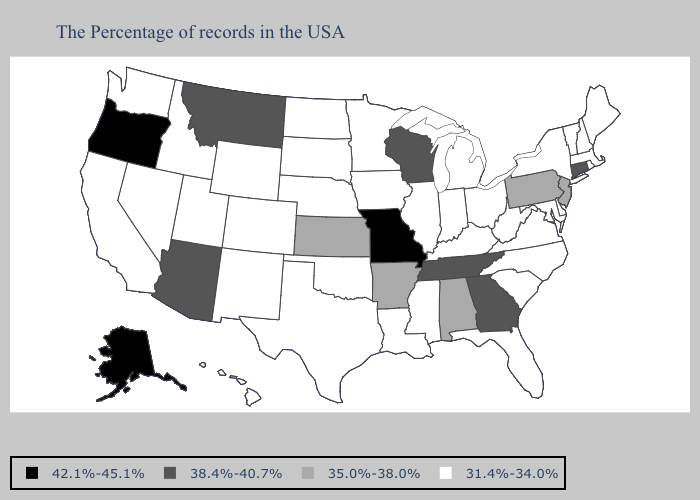What is the value of Massachusetts?
Quick response, please. 31.4%-34.0%. Does Nebraska have the highest value in the MidWest?
Give a very brief answer. No. What is the value of Idaho?
Give a very brief answer. 31.4%-34.0%. Does the first symbol in the legend represent the smallest category?
Concise answer only. No. What is the value of Ohio?
Keep it brief. 31.4%-34.0%. Name the states that have a value in the range 35.0%-38.0%?
Keep it brief. New Jersey, Pennsylvania, Alabama, Arkansas, Kansas. Among the states that border South Carolina , which have the highest value?
Write a very short answer. Georgia. Among the states that border Massachusetts , does Rhode Island have the lowest value?
Concise answer only. Yes. Which states hav the highest value in the South?
Be succinct. Georgia, Tennessee. Name the states that have a value in the range 42.1%-45.1%?
Be succinct. Missouri, Oregon, Alaska. What is the value of Maine?
Give a very brief answer. 31.4%-34.0%. Among the states that border Florida , which have the highest value?
Quick response, please. Georgia. Name the states that have a value in the range 42.1%-45.1%?
Keep it brief. Missouri, Oregon, Alaska. 